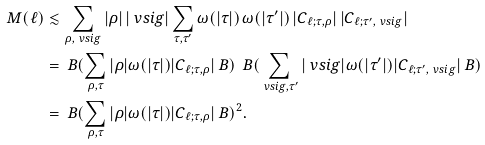Convert formula to latex. <formula><loc_0><loc_0><loc_500><loc_500>M ( \ell ) & \lesssim \sum _ { \rho , \ v s i g } | \rho | \, | \ v s i g | \sum _ { \tau , \tau ^ { \prime } } \omega ( | \tau | ) \, \omega ( | \tau ^ { \prime } | ) \, | C _ { \ell ; \tau , \rho } | \, | C _ { \ell ; \tau ^ { \prime } , \ v s i g } | \\ & = \ B ( \sum _ { \rho , \tau } | \rho | \omega ( | \tau | ) | C _ { \ell ; \tau , \rho } | \ B ) \, \ B ( \sum _ { \ v s i g , \tau ^ { \prime } } | \ v s i g | \omega ( | \tau ^ { \prime } | ) | C _ { \ell ; \tau ^ { \prime } , \ v s i g } | \ B ) \\ & = \ B ( \sum _ { \rho , \tau } | \rho | \omega ( | \tau | ) | C _ { \ell ; \tau , \rho } | \ B ) ^ { 2 } .</formula> 